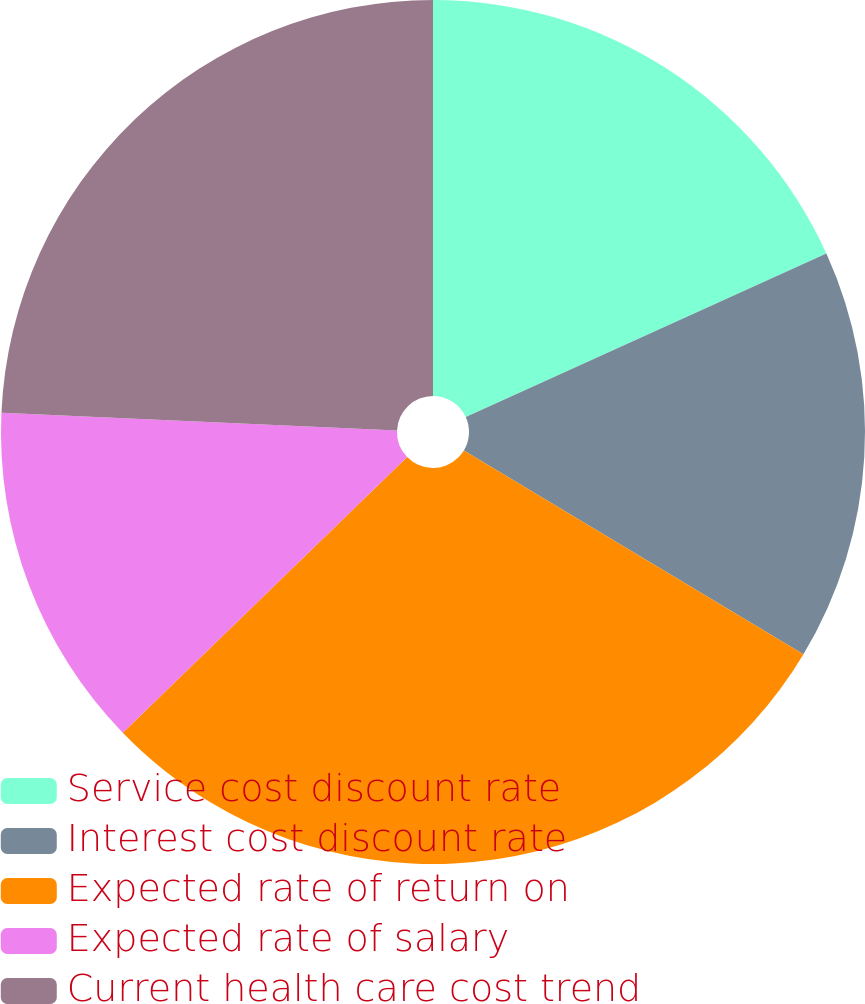<chart> <loc_0><loc_0><loc_500><loc_500><pie_chart><fcel>Service cost discount rate<fcel>Interest cost discount rate<fcel>Expected rate of return on<fcel>Expected rate of salary<fcel>Current health care cost trend<nl><fcel>18.22%<fcel>15.38%<fcel>29.15%<fcel>12.96%<fcel>24.29%<nl></chart> 